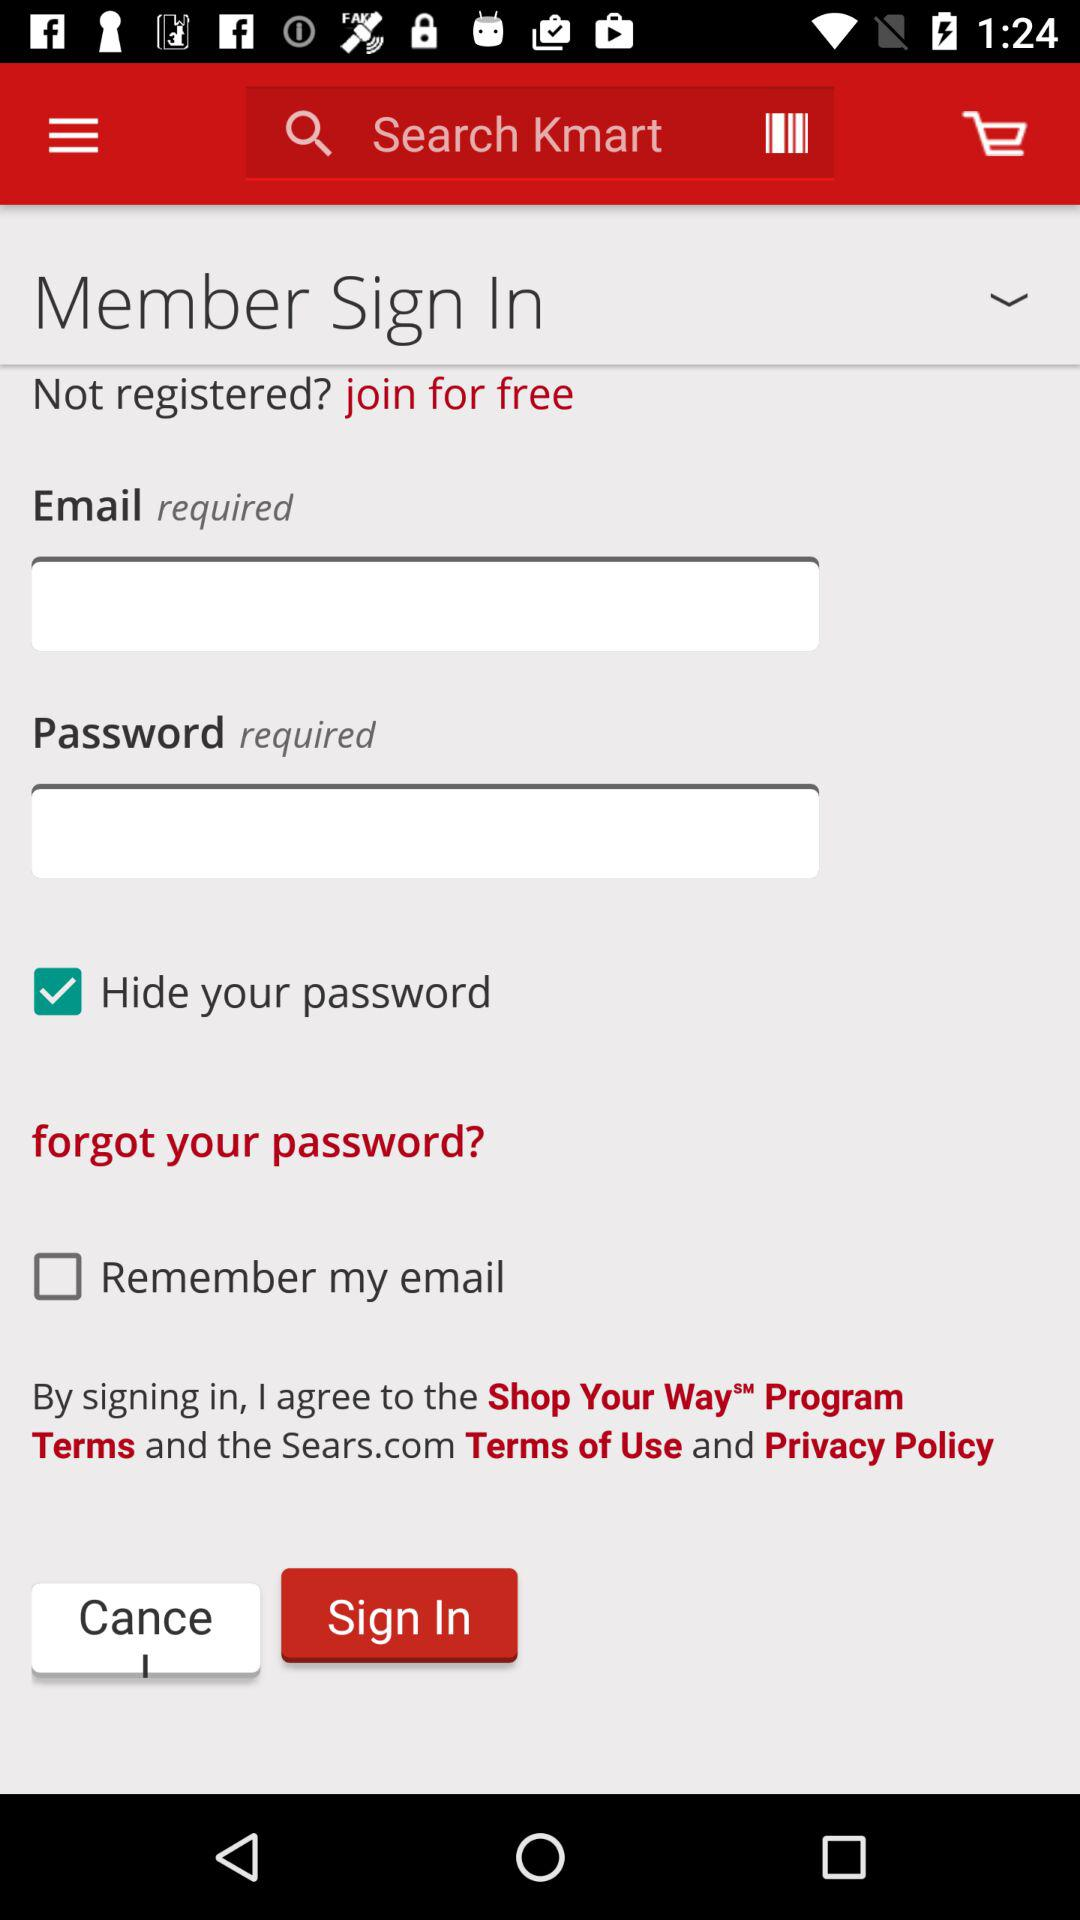How many checkboxes are in the sign in form?
Answer the question using a single word or phrase. 2 